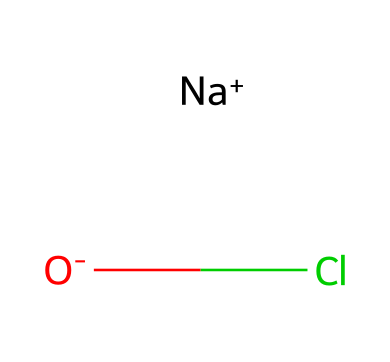What elements are present in this chemical? The chemical structure indicates the presence of sodium (Na), chlorine (Cl), and oxygen (O). These elements can be identified from their corresponding symbols in the SMILES representation.
Answer: sodium, chlorine, oxygen How many total atoms are in this compound? Counting the individual atoms present in the SMILES, we have one sodium atom, one chlorine atom, and one oxygen atom, totaling three atoms.
Answer: three What type of bond connects chlorine in this compound? Chlorine (Cl) in this compound is connected through an ionic bond with sodium (Na) and has an ionic interaction with the oxygen (O) as represented by the charge separation in the SMILES.
Answer: ionic bond Is this compound soluble in water? Given the presence of sodium (Na+) and chloride (Cl-) ions, this compound would be ionic and is generally soluble in water due to the ability of water molecules to surround and stabilize ions.
Answer: yes What is the formal charge on oxygen in this compound? The oxygen atom in this compound has a formal negative charge indicated by the "[O-]" representation in the SMILES, which suggests that it has gained an electron compared to its neutral state.
Answer: negative Does this compound contain a halogen? Yes, chlorine (Cl) is a halogen and is explicitly represented in the chemical structure, confirming the presence of a halogen in this compound.
Answer: yes 